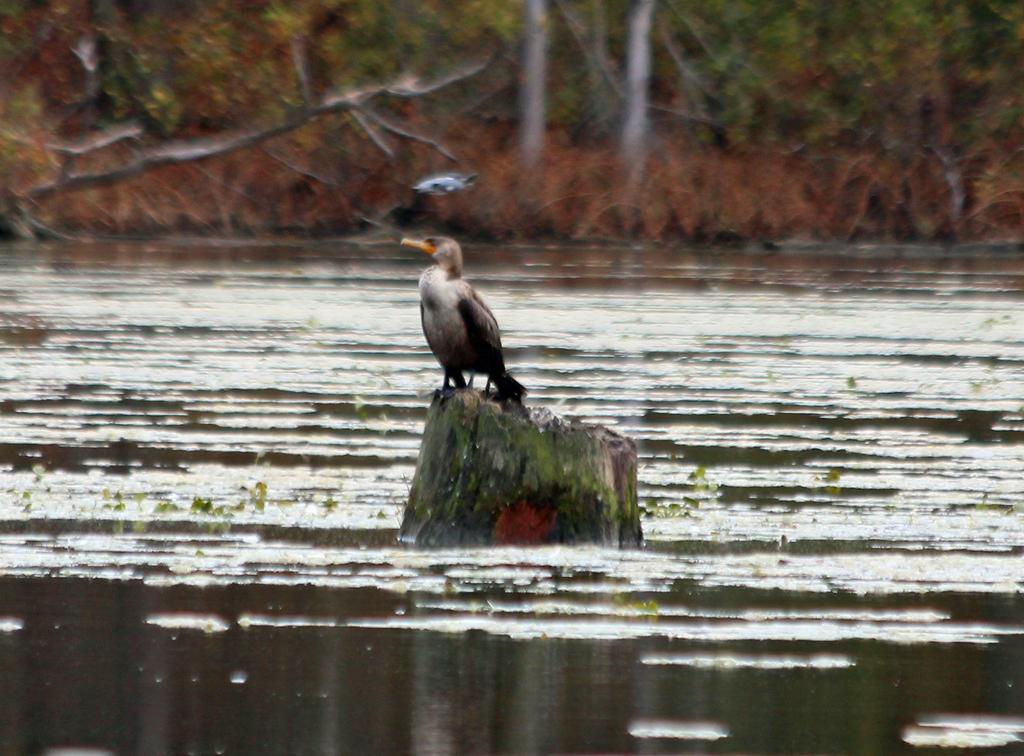What type of animal can be seen in the image? There is a small bird in the image. Where is the bird located? The bird is sitting on a tree trunk. What natural feature is visible in the image? There is a river with water in the image. What color are the leaves on the trees in the image? The tree leaves in the image are red in color. What type of slope can be seen in the image? There is no slope present in the image. How does the bird start its journey in the image? The image does not depict the bird starting its journey; it shows the bird sitting on a tree trunk. 